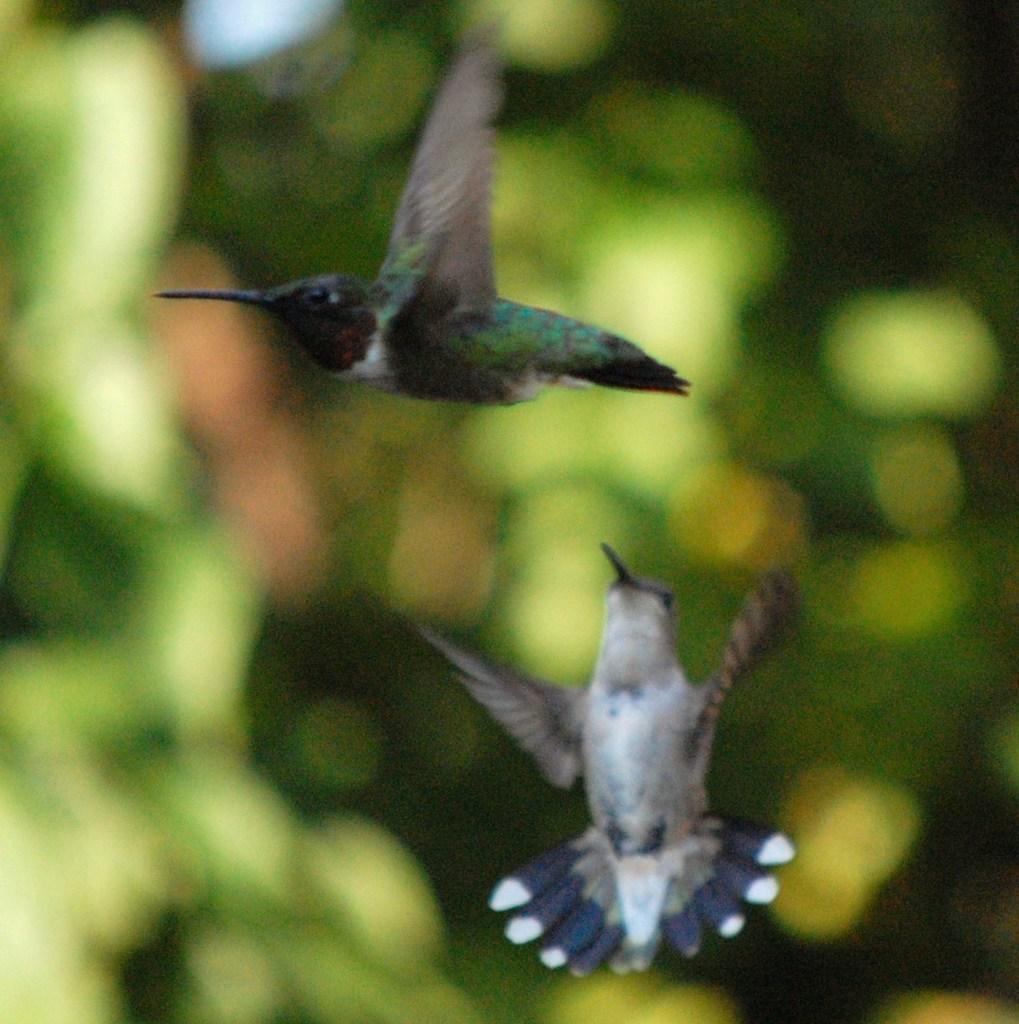Could you give a brief overview of what you see in this image? In this picture there are birds flying. At the back image is blurry and there are trees. 